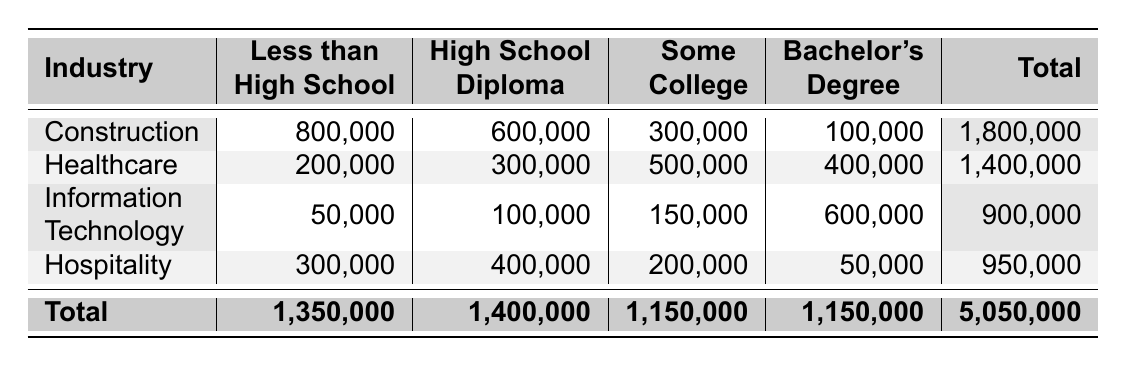What is the total number of immigrant workers in the Construction industry? The total for Construction is listed at the bottom row in the total column, which sums individual education levels (800,000 + 600,000 + 300,000 + 100,000) = 1,800,000.
Answer: 1,800,000 How many immigrant workers in Healthcare have a Bachelor's Degree? The specific count for immigrant workers in Healthcare with a Bachelor's Degree is given directly in the table as 400,000.
Answer: 400,000 Which industry has the highest number of immigrant workers in the "Less than High School" category? By comparing the "Less than High School" values across industries, Construction has 800,000, Healthcare has 200,000, Information Technology has 50,000, and Hospitality has 300,000. The highest is Construction with 800,000.
Answer: Construction What is the average number of immigrant workers for the education level "Some College"? To find the average, first sum the values (300,000 + 500,000 + 150,000 + 200,000) = 1,150,000. There are 4 industries, so the average is 1,150,000 / 4 = 287,500.
Answer: 287,500 Is it true that more immigrant workers have a High School Diploma in Hospitality than in Construction? Looking at the table, Hospitality has 400,000 and Construction has 600,000. Therefore, it is not true that Hospitality has more; Construction has 600,000 compared to Hospitality's 400,000.
Answer: No Which education level has the least number of immigrant workers in the Information Technology sector? In the Information Technology sector, the numbers are 50,000 for Less than High School, 100,000 for High School Diploma, 150,000 for Some College, and 600,000 for Bachelor's Degree. The least is 50,000 for Less than High School.
Answer: Less than High School How many immigrant workers are in the Hospitality industry compared to the total immigrant workers across all industries? The total for the Hospitality industry is listed as 950,000, and the overall total from the table is 5,050,000. To see how they relate, we can see that Hospitality contributes 950,000 out of 5,050,000 in total.
Answer: 950,000 What is the difference in the number of immigrant workers with some college education between Healthcare and Hospitality? For Healthcare, the number is 500,000, and for Hospitality, it is 200,000. The difference is 500,000 - 200,000 = 300,000.
Answer: 300,000 Are there more immigrant workers with less than a high school education in the Healthcare industry than in Information Technology? The count for Healthcare with Less than High School is 200,000, while Information Technology has 50,000. Therefore, it is true that Healthcare has more.
Answer: Yes 